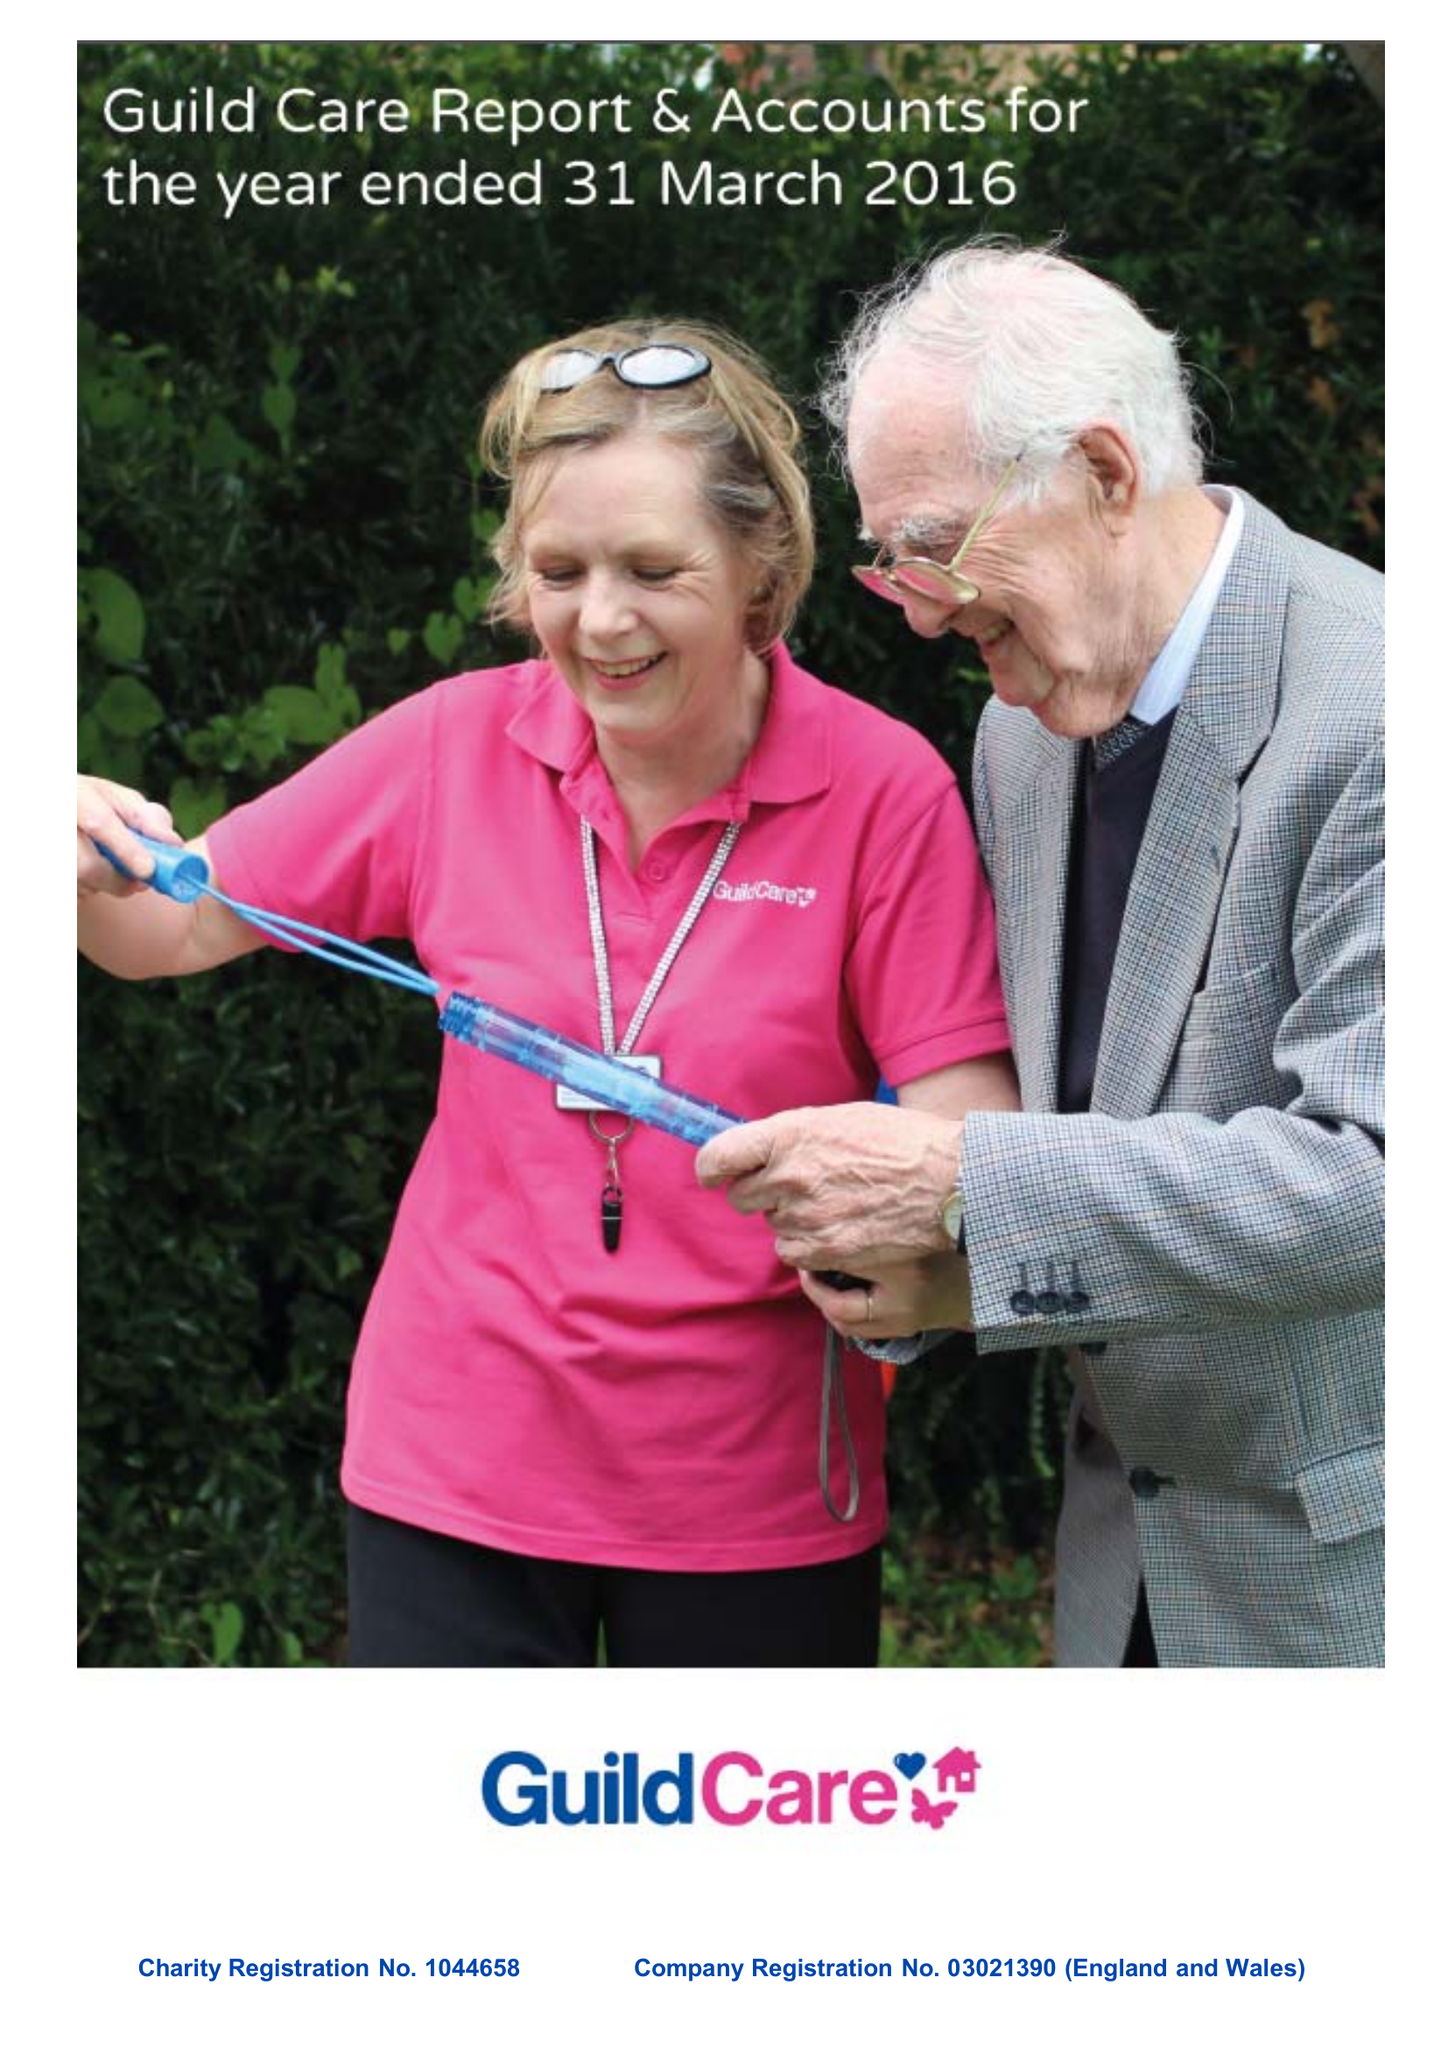What is the value for the address__postcode?
Answer the question using a single word or phrase. BN11 1DU 